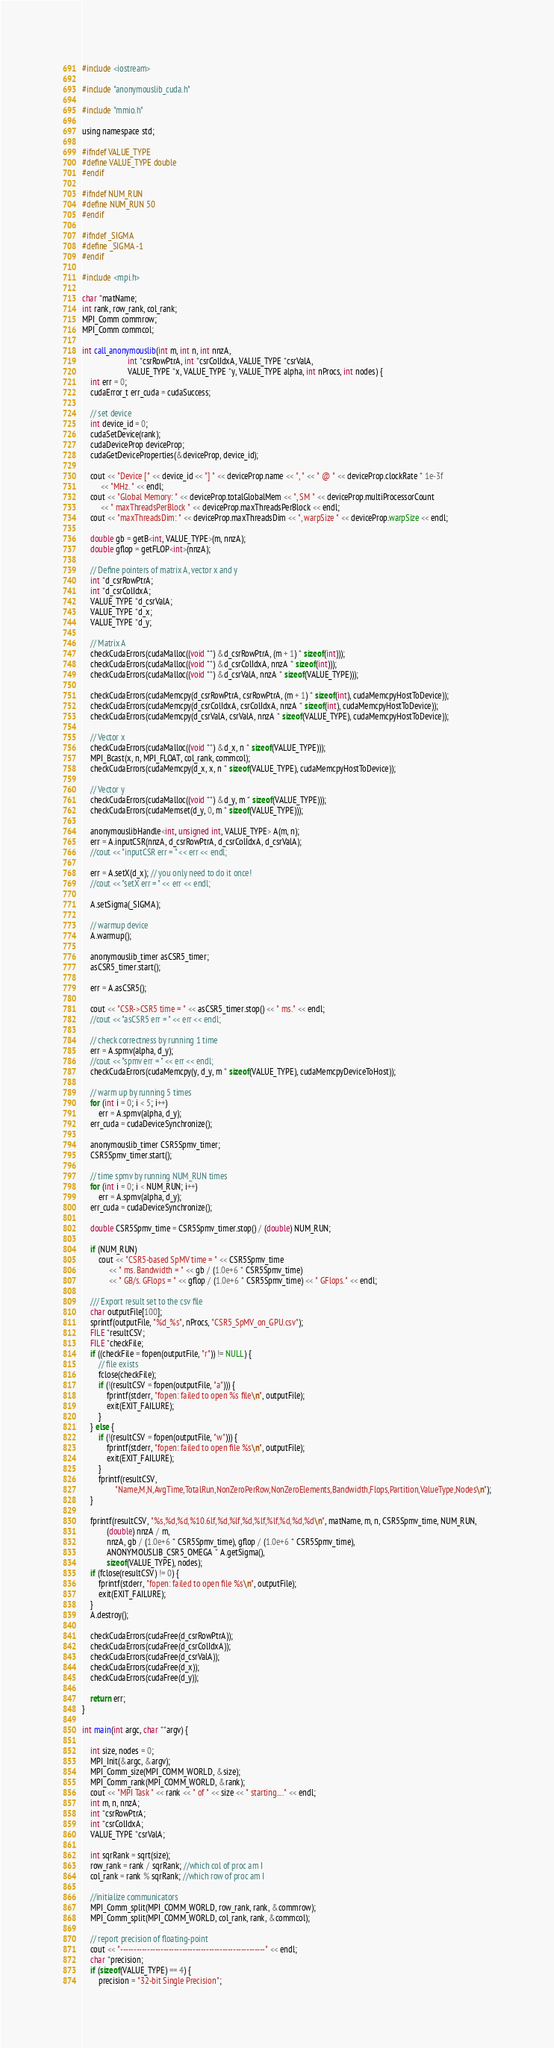Convert code to text. <code><loc_0><loc_0><loc_500><loc_500><_Cuda_>#include <iostream>

#include "anonymouslib_cuda.h"

#include "mmio.h"

using namespace std;

#ifndef VALUE_TYPE
#define VALUE_TYPE double
#endif

#ifndef NUM_RUN
#define NUM_RUN 50
#endif

#ifndef _SIGMA
#define _SIGMA -1
#endif

#include <mpi.h>

char *matName;
int rank, row_rank, col_rank;
MPI_Comm commrow;
MPI_Comm commcol;

int call_anonymouslib(int m, int n, int nnzA,
                      int *csrRowPtrA, int *csrColIdxA, VALUE_TYPE *csrValA,
                      VALUE_TYPE *x, VALUE_TYPE *y, VALUE_TYPE alpha, int nProcs, int nodes) {
    int err = 0;
    cudaError_t err_cuda = cudaSuccess;

    // set device
    int device_id = 0;
    cudaSetDevice(rank);
    cudaDeviceProp deviceProp;
    cudaGetDeviceProperties(&deviceProp, device_id);

    cout << "Device [" << device_id << "] " << deviceProp.name << ", " << " @ " << deviceProp.clockRate * 1e-3f
         << "MHz. " << endl;
    cout << "Global Memory: " << deviceProp.totalGlobalMem << ", SM " << deviceProp.multiProcessorCount
         << " maxThreadsPerBlock " << deviceProp.maxThreadsPerBlock << endl;
    cout << "maxThreadsDim: " << deviceProp.maxThreadsDim << ", warpSize " << deviceProp.warpSize << endl;

    double gb = getB<int, VALUE_TYPE>(m, nnzA);
    double gflop = getFLOP<int>(nnzA);

    // Define pointers of matrix A, vector x and y
    int *d_csrRowPtrA;
    int *d_csrColIdxA;
    VALUE_TYPE *d_csrValA;
    VALUE_TYPE *d_x;
    VALUE_TYPE *d_y;

    // Matrix A
    checkCudaErrors(cudaMalloc((void **) &d_csrRowPtrA, (m + 1) * sizeof(int)));
    checkCudaErrors(cudaMalloc((void **) &d_csrColIdxA, nnzA * sizeof(int)));
    checkCudaErrors(cudaMalloc((void **) &d_csrValA, nnzA * sizeof(VALUE_TYPE)));

    checkCudaErrors(cudaMemcpy(d_csrRowPtrA, csrRowPtrA, (m + 1) * sizeof(int), cudaMemcpyHostToDevice));
    checkCudaErrors(cudaMemcpy(d_csrColIdxA, csrColIdxA, nnzA * sizeof(int), cudaMemcpyHostToDevice));
    checkCudaErrors(cudaMemcpy(d_csrValA, csrValA, nnzA * sizeof(VALUE_TYPE), cudaMemcpyHostToDevice));

    // Vector x
    checkCudaErrors(cudaMalloc((void **) &d_x, n * sizeof(VALUE_TYPE)));
    MPI_Bcast(x, n, MPI_FLOAT, col_rank, commcol);
    checkCudaErrors(cudaMemcpy(d_x, x, n * sizeof(VALUE_TYPE), cudaMemcpyHostToDevice));

    // Vector y
    checkCudaErrors(cudaMalloc((void **) &d_y, m * sizeof(VALUE_TYPE)));
    checkCudaErrors(cudaMemset(d_y, 0, m * sizeof(VALUE_TYPE)));

    anonymouslibHandle<int, unsigned int, VALUE_TYPE> A(m, n);
    err = A.inputCSR(nnzA, d_csrRowPtrA, d_csrColIdxA, d_csrValA);
    //cout << "inputCSR err = " << err << endl;

    err = A.setX(d_x); // you only need to do it once!
    //cout << "setX err = " << err << endl;

    A.setSigma(_SIGMA);

    // warmup device
    A.warmup();

    anonymouslib_timer asCSR5_timer;
    asCSR5_timer.start();

    err = A.asCSR5();

    cout << "CSR->CSR5 time = " << asCSR5_timer.stop() << " ms." << endl;
    //cout << "asCSR5 err = " << err << endl;

    // check correctness by running 1 time
    err = A.spmv(alpha, d_y);
    //cout << "spmv err = " << err << endl;
    checkCudaErrors(cudaMemcpy(y, d_y, m * sizeof(VALUE_TYPE), cudaMemcpyDeviceToHost));

    // warm up by running 5 times
    for (int i = 0; i < 5; i++)
        err = A.spmv(alpha, d_y);
    err_cuda = cudaDeviceSynchronize();

    anonymouslib_timer CSR5Spmv_timer;
    CSR5Spmv_timer.start();

    // time spmv by running NUM_RUN times
    for (int i = 0; i < NUM_RUN; i++)
        err = A.spmv(alpha, d_y);
    err_cuda = cudaDeviceSynchronize();

    double CSR5Spmv_time = CSR5Spmv_timer.stop() / (double) NUM_RUN;

    if (NUM_RUN)
        cout << "CSR5-based SpMV time = " << CSR5Spmv_time
             << " ms. Bandwidth = " << gb / (1.0e+6 * CSR5Spmv_time)
             << " GB/s. GFlops = " << gflop / (1.0e+6 * CSR5Spmv_time) << " GFlops." << endl;

    /// Export result set to the csv file
    char outputFile[100];
    sprintf(outputFile, "%d_%s", nProcs, "CSR5_SpMV_on_GPU.csv");
    FILE *resultCSV;
    FILE *checkFile;
    if ((checkFile = fopen(outputFile, "r")) != NULL) {
        // file exists
        fclose(checkFile);
        if (!(resultCSV = fopen(outputFile, "a"))) {
            fprintf(stderr, "fopen: failed to open %s file\n", outputFile);
            exit(EXIT_FAILURE);
        }
    } else {
        if (!(resultCSV = fopen(outputFile, "w"))) {
            fprintf(stderr, "fopen: failed to open file %s\n", outputFile);
            exit(EXIT_FAILURE);
        }
        fprintf(resultCSV,
                "Name,M,N,AvgTime,TotalRun,NonZeroPerRow,NonZeroElements,Bandwidth,Flops,Partition,ValueType,Nodes\n");
    }

    fprintf(resultCSV, "%s,%d,%d,%10.6lf,%d,%lf,%d,%lf,%lf,%d,%d,%d\n", matName, m, n, CSR5Spmv_time, NUM_RUN,
            (double) nnzA / m,
            nnzA, gb / (1.0e+6 * CSR5Spmv_time), gflop / (1.0e+6 * CSR5Spmv_time),
            ANONYMOUSLIB_CSR5_OMEGA * A.getSigma(),
            sizeof(VALUE_TYPE), nodes);
    if (fclose(resultCSV) != 0) {
        fprintf(stderr, "fopen: failed to open file %s\n", outputFile);
        exit(EXIT_FAILURE);
    }
    A.destroy();

    checkCudaErrors(cudaFree(d_csrRowPtrA));
    checkCudaErrors(cudaFree(d_csrColIdxA));
    checkCudaErrors(cudaFree(d_csrValA));
    checkCudaErrors(cudaFree(d_x));
    checkCudaErrors(cudaFree(d_y));

    return err;
}

int main(int argc, char **argv) {

    int size, nodes = 0;
    MPI_Init(&argc, &argv);
    MPI_Comm_size(MPI_COMM_WORLD, &size);
    MPI_Comm_rank(MPI_COMM_WORLD, &rank);
    cout << "MPI Task " << rank << " of " << size << " starting...." << endl;
    int m, n, nnzA;
    int *csrRowPtrA;
    int *csrColIdxA;
    VALUE_TYPE *csrValA;

    int sqrRank = sqrt(size);
    row_rank = rank / sqrRank; //which col of proc am I
    col_rank = rank % sqrRank; //which row of proc am I

    //initialize communicators
    MPI_Comm_split(MPI_COMM_WORLD, row_rank, rank, &commrow);
    MPI_Comm_split(MPI_COMM_WORLD, col_rank, rank, &commcol);

    // report precision of floating-point
    cout << "------------------------------------------------------" << endl;
    char *precision;
    if (sizeof(VALUE_TYPE) == 4) {
        precision = "32-bit Single Precision";</code> 